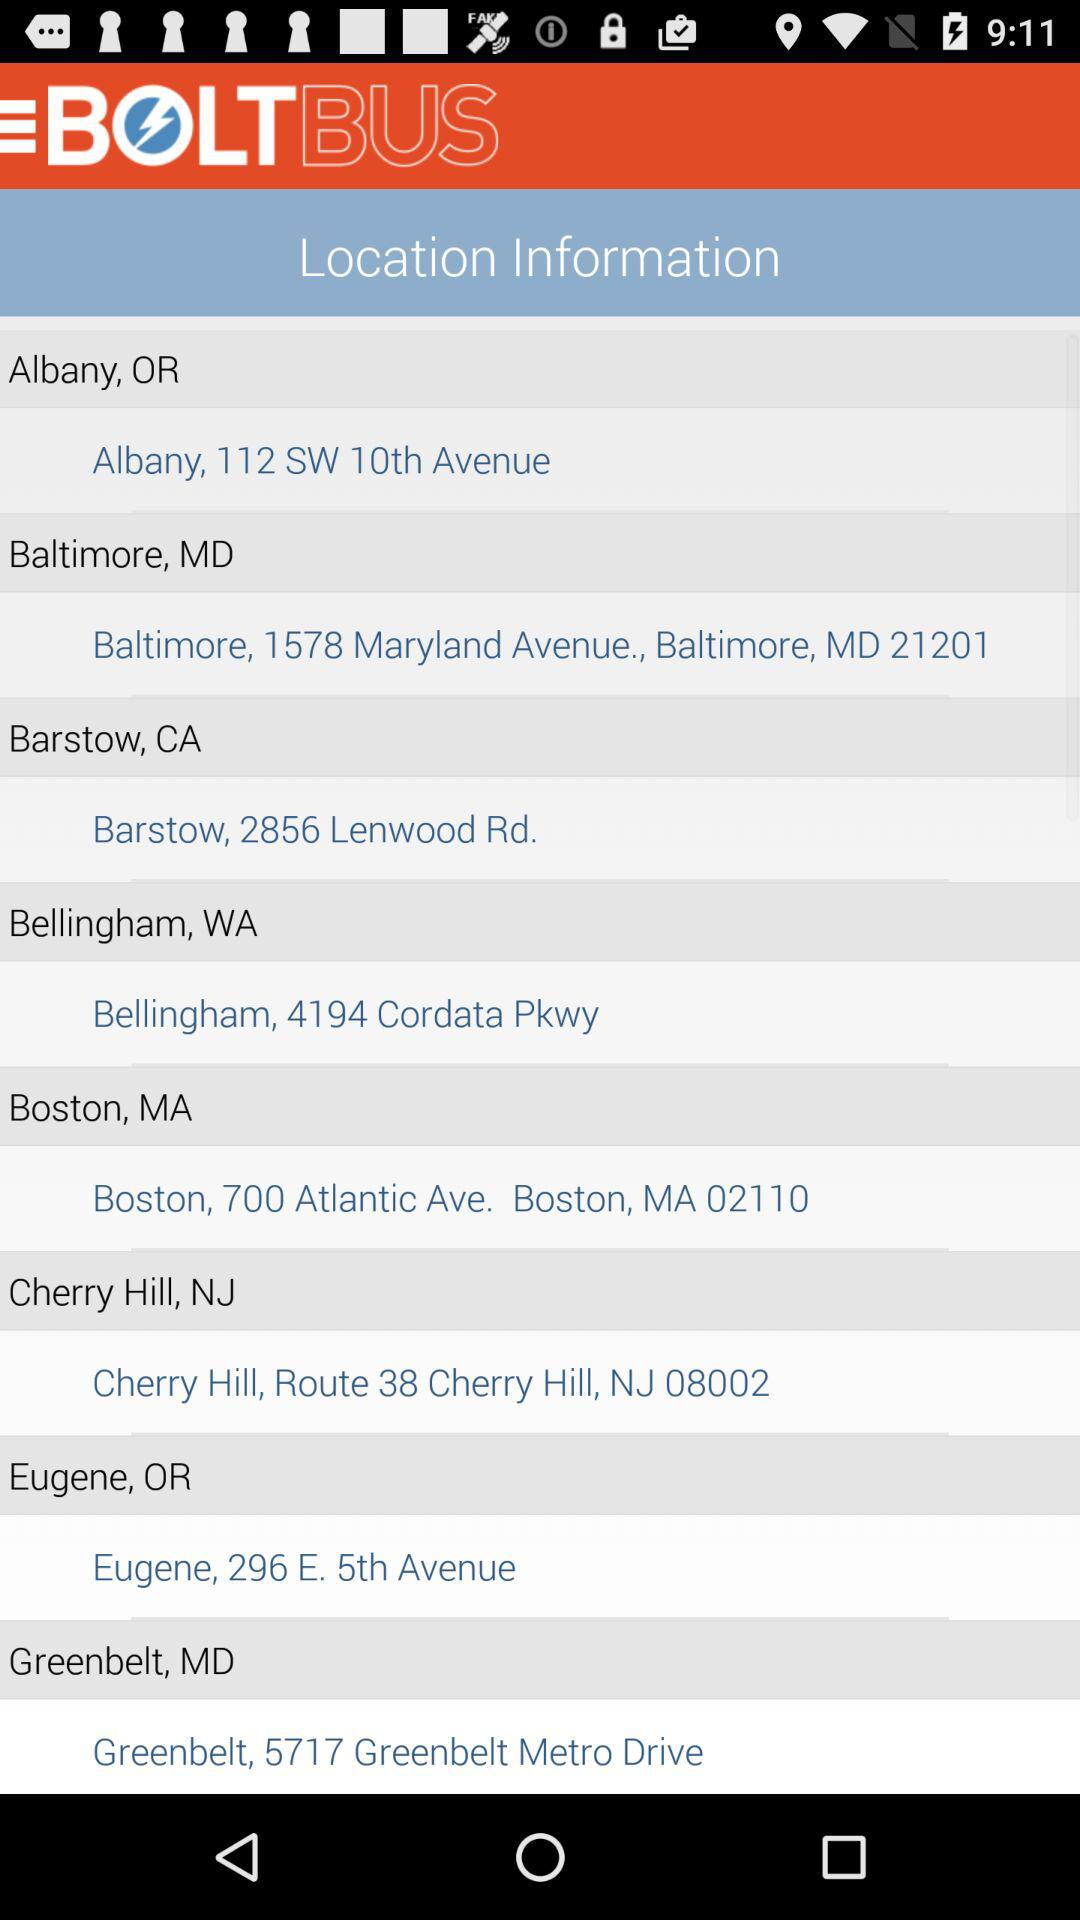What are the different bus locations available? The available locations are Albany, OR, Baltimore, MD, Barstow, CA, Bellingham, WA, Boston, MA, Cherry Hill, NJ, Eugene, OR and Greenbelt, MD. 